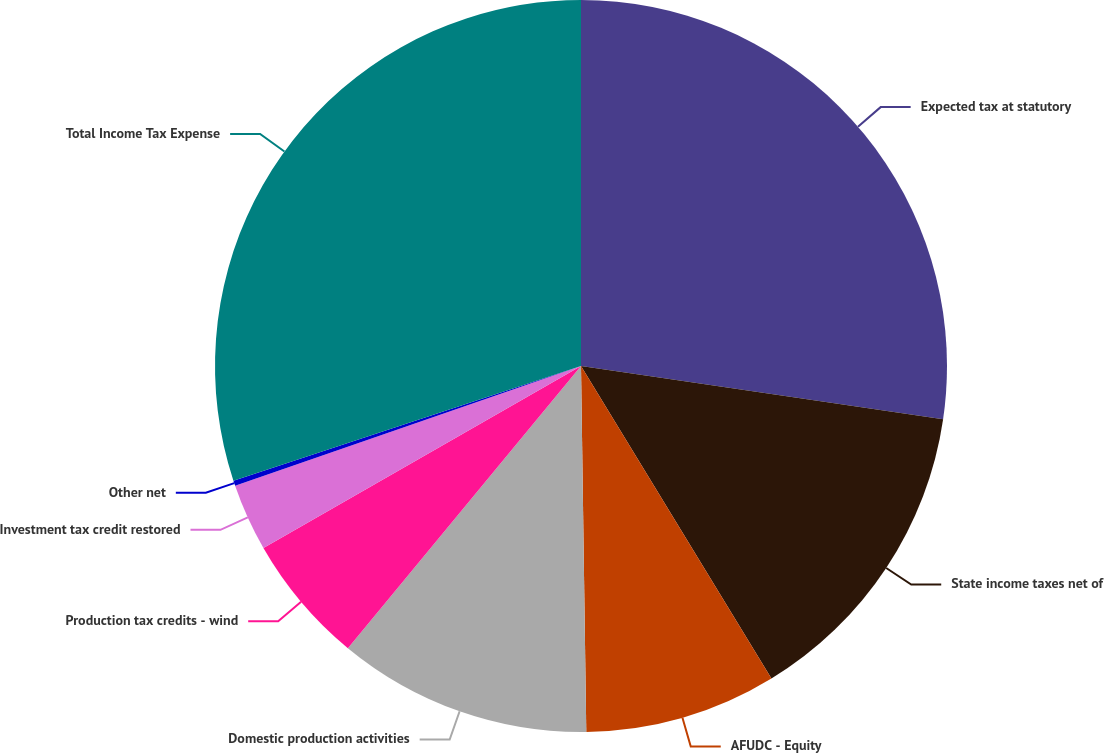<chart> <loc_0><loc_0><loc_500><loc_500><pie_chart><fcel>Expected tax at statutory<fcel>State income taxes net of<fcel>AFUDC - Equity<fcel>Domestic production activities<fcel>Production tax credits - wind<fcel>Investment tax credit restored<fcel>Other net<fcel>Total Income Tax Expense<nl><fcel>27.32%<fcel>13.97%<fcel>8.48%<fcel>11.22%<fcel>5.73%<fcel>2.98%<fcel>0.23%<fcel>30.07%<nl></chart> 